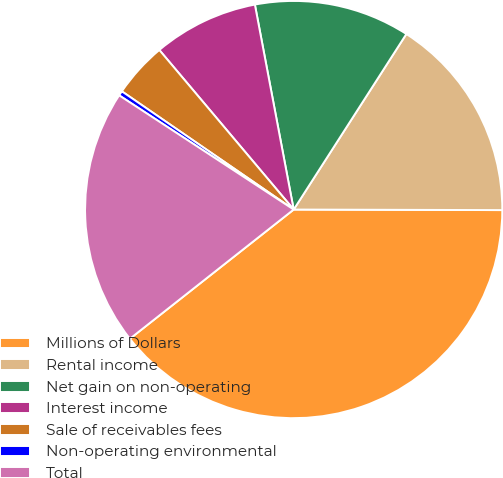Convert chart. <chart><loc_0><loc_0><loc_500><loc_500><pie_chart><fcel>Millions of Dollars<fcel>Rental income<fcel>Net gain on non-operating<fcel>Interest income<fcel>Sale of receivables fees<fcel>Non-operating environmental<fcel>Total<nl><fcel>39.33%<fcel>15.96%<fcel>12.06%<fcel>8.16%<fcel>4.27%<fcel>0.37%<fcel>19.85%<nl></chart> 